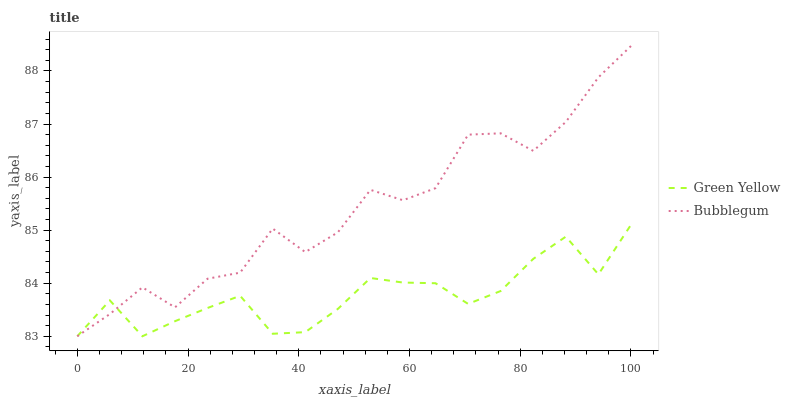Does Green Yellow have the minimum area under the curve?
Answer yes or no. Yes. Does Bubblegum have the maximum area under the curve?
Answer yes or no. Yes. Does Bubblegum have the minimum area under the curve?
Answer yes or no. No. Is Green Yellow the smoothest?
Answer yes or no. Yes. Is Bubblegum the roughest?
Answer yes or no. Yes. Is Bubblegum the smoothest?
Answer yes or no. No. Does Green Yellow have the lowest value?
Answer yes or no. Yes. Does Bubblegum have the highest value?
Answer yes or no. Yes. Does Green Yellow intersect Bubblegum?
Answer yes or no. Yes. Is Green Yellow less than Bubblegum?
Answer yes or no. No. Is Green Yellow greater than Bubblegum?
Answer yes or no. No. 